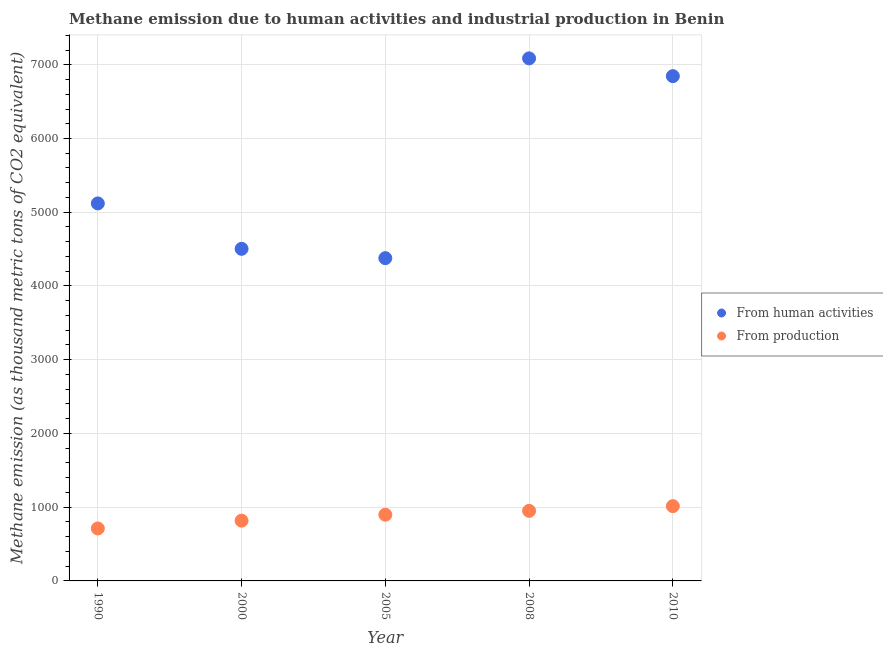How many different coloured dotlines are there?
Your answer should be very brief. 2. What is the amount of emissions from human activities in 1990?
Offer a terse response. 5119.5. Across all years, what is the maximum amount of emissions generated from industries?
Keep it short and to the point. 1014.3. Across all years, what is the minimum amount of emissions generated from industries?
Provide a short and direct response. 711.4. In which year was the amount of emissions from human activities minimum?
Your answer should be compact. 2005. What is the total amount of emissions generated from industries in the graph?
Offer a terse response. 4391.4. What is the difference between the amount of emissions generated from industries in 1990 and that in 2008?
Your answer should be very brief. -239. What is the difference between the amount of emissions from human activities in 1990 and the amount of emissions generated from industries in 2008?
Provide a short and direct response. 4169.1. What is the average amount of emissions from human activities per year?
Give a very brief answer. 5586.56. In the year 1990, what is the difference between the amount of emissions generated from industries and amount of emissions from human activities?
Your answer should be very brief. -4408.1. What is the ratio of the amount of emissions generated from industries in 1990 to that in 2005?
Give a very brief answer. 0.79. Is the amount of emissions from human activities in 2005 less than that in 2008?
Provide a short and direct response. Yes. What is the difference between the highest and the second highest amount of emissions generated from industries?
Offer a terse response. 63.9. What is the difference between the highest and the lowest amount of emissions from human activities?
Offer a very short reply. 2709.3. Is the amount of emissions from human activities strictly greater than the amount of emissions generated from industries over the years?
Ensure brevity in your answer.  Yes. Is the amount of emissions generated from industries strictly less than the amount of emissions from human activities over the years?
Give a very brief answer. Yes. How many dotlines are there?
Provide a short and direct response. 2. How many years are there in the graph?
Offer a very short reply. 5. Does the graph contain grids?
Keep it short and to the point. Yes. What is the title of the graph?
Provide a succinct answer. Methane emission due to human activities and industrial production in Benin. What is the label or title of the Y-axis?
Your response must be concise. Methane emission (as thousand metric tons of CO2 equivalent). What is the Methane emission (as thousand metric tons of CO2 equivalent) in From human activities in 1990?
Your answer should be compact. 5119.5. What is the Methane emission (as thousand metric tons of CO2 equivalent) in From production in 1990?
Provide a short and direct response. 711.4. What is the Methane emission (as thousand metric tons of CO2 equivalent) of From human activities in 2000?
Ensure brevity in your answer.  4503.8. What is the Methane emission (as thousand metric tons of CO2 equivalent) in From production in 2000?
Your answer should be compact. 817.2. What is the Methane emission (as thousand metric tons of CO2 equivalent) of From human activities in 2005?
Offer a very short reply. 4377.3. What is the Methane emission (as thousand metric tons of CO2 equivalent) of From production in 2005?
Your answer should be compact. 898.1. What is the Methane emission (as thousand metric tons of CO2 equivalent) in From human activities in 2008?
Your answer should be very brief. 7086.6. What is the Methane emission (as thousand metric tons of CO2 equivalent) of From production in 2008?
Provide a succinct answer. 950.4. What is the Methane emission (as thousand metric tons of CO2 equivalent) of From human activities in 2010?
Offer a terse response. 6845.6. What is the Methane emission (as thousand metric tons of CO2 equivalent) of From production in 2010?
Your answer should be compact. 1014.3. Across all years, what is the maximum Methane emission (as thousand metric tons of CO2 equivalent) in From human activities?
Offer a terse response. 7086.6. Across all years, what is the maximum Methane emission (as thousand metric tons of CO2 equivalent) in From production?
Make the answer very short. 1014.3. Across all years, what is the minimum Methane emission (as thousand metric tons of CO2 equivalent) of From human activities?
Offer a very short reply. 4377.3. Across all years, what is the minimum Methane emission (as thousand metric tons of CO2 equivalent) in From production?
Provide a short and direct response. 711.4. What is the total Methane emission (as thousand metric tons of CO2 equivalent) in From human activities in the graph?
Ensure brevity in your answer.  2.79e+04. What is the total Methane emission (as thousand metric tons of CO2 equivalent) in From production in the graph?
Keep it short and to the point. 4391.4. What is the difference between the Methane emission (as thousand metric tons of CO2 equivalent) in From human activities in 1990 and that in 2000?
Your answer should be very brief. 615.7. What is the difference between the Methane emission (as thousand metric tons of CO2 equivalent) of From production in 1990 and that in 2000?
Make the answer very short. -105.8. What is the difference between the Methane emission (as thousand metric tons of CO2 equivalent) of From human activities in 1990 and that in 2005?
Offer a very short reply. 742.2. What is the difference between the Methane emission (as thousand metric tons of CO2 equivalent) of From production in 1990 and that in 2005?
Give a very brief answer. -186.7. What is the difference between the Methane emission (as thousand metric tons of CO2 equivalent) in From human activities in 1990 and that in 2008?
Your response must be concise. -1967.1. What is the difference between the Methane emission (as thousand metric tons of CO2 equivalent) of From production in 1990 and that in 2008?
Provide a short and direct response. -239. What is the difference between the Methane emission (as thousand metric tons of CO2 equivalent) of From human activities in 1990 and that in 2010?
Provide a short and direct response. -1726.1. What is the difference between the Methane emission (as thousand metric tons of CO2 equivalent) of From production in 1990 and that in 2010?
Your answer should be very brief. -302.9. What is the difference between the Methane emission (as thousand metric tons of CO2 equivalent) of From human activities in 2000 and that in 2005?
Offer a terse response. 126.5. What is the difference between the Methane emission (as thousand metric tons of CO2 equivalent) in From production in 2000 and that in 2005?
Ensure brevity in your answer.  -80.9. What is the difference between the Methane emission (as thousand metric tons of CO2 equivalent) of From human activities in 2000 and that in 2008?
Make the answer very short. -2582.8. What is the difference between the Methane emission (as thousand metric tons of CO2 equivalent) in From production in 2000 and that in 2008?
Your response must be concise. -133.2. What is the difference between the Methane emission (as thousand metric tons of CO2 equivalent) of From human activities in 2000 and that in 2010?
Make the answer very short. -2341.8. What is the difference between the Methane emission (as thousand metric tons of CO2 equivalent) in From production in 2000 and that in 2010?
Your response must be concise. -197.1. What is the difference between the Methane emission (as thousand metric tons of CO2 equivalent) in From human activities in 2005 and that in 2008?
Your response must be concise. -2709.3. What is the difference between the Methane emission (as thousand metric tons of CO2 equivalent) of From production in 2005 and that in 2008?
Ensure brevity in your answer.  -52.3. What is the difference between the Methane emission (as thousand metric tons of CO2 equivalent) in From human activities in 2005 and that in 2010?
Give a very brief answer. -2468.3. What is the difference between the Methane emission (as thousand metric tons of CO2 equivalent) of From production in 2005 and that in 2010?
Offer a very short reply. -116.2. What is the difference between the Methane emission (as thousand metric tons of CO2 equivalent) of From human activities in 2008 and that in 2010?
Your answer should be very brief. 241. What is the difference between the Methane emission (as thousand metric tons of CO2 equivalent) in From production in 2008 and that in 2010?
Keep it short and to the point. -63.9. What is the difference between the Methane emission (as thousand metric tons of CO2 equivalent) of From human activities in 1990 and the Methane emission (as thousand metric tons of CO2 equivalent) of From production in 2000?
Your answer should be compact. 4302.3. What is the difference between the Methane emission (as thousand metric tons of CO2 equivalent) in From human activities in 1990 and the Methane emission (as thousand metric tons of CO2 equivalent) in From production in 2005?
Make the answer very short. 4221.4. What is the difference between the Methane emission (as thousand metric tons of CO2 equivalent) of From human activities in 1990 and the Methane emission (as thousand metric tons of CO2 equivalent) of From production in 2008?
Ensure brevity in your answer.  4169.1. What is the difference between the Methane emission (as thousand metric tons of CO2 equivalent) in From human activities in 1990 and the Methane emission (as thousand metric tons of CO2 equivalent) in From production in 2010?
Offer a very short reply. 4105.2. What is the difference between the Methane emission (as thousand metric tons of CO2 equivalent) of From human activities in 2000 and the Methane emission (as thousand metric tons of CO2 equivalent) of From production in 2005?
Offer a very short reply. 3605.7. What is the difference between the Methane emission (as thousand metric tons of CO2 equivalent) of From human activities in 2000 and the Methane emission (as thousand metric tons of CO2 equivalent) of From production in 2008?
Ensure brevity in your answer.  3553.4. What is the difference between the Methane emission (as thousand metric tons of CO2 equivalent) of From human activities in 2000 and the Methane emission (as thousand metric tons of CO2 equivalent) of From production in 2010?
Your answer should be very brief. 3489.5. What is the difference between the Methane emission (as thousand metric tons of CO2 equivalent) in From human activities in 2005 and the Methane emission (as thousand metric tons of CO2 equivalent) in From production in 2008?
Offer a terse response. 3426.9. What is the difference between the Methane emission (as thousand metric tons of CO2 equivalent) in From human activities in 2005 and the Methane emission (as thousand metric tons of CO2 equivalent) in From production in 2010?
Make the answer very short. 3363. What is the difference between the Methane emission (as thousand metric tons of CO2 equivalent) in From human activities in 2008 and the Methane emission (as thousand metric tons of CO2 equivalent) in From production in 2010?
Provide a short and direct response. 6072.3. What is the average Methane emission (as thousand metric tons of CO2 equivalent) of From human activities per year?
Make the answer very short. 5586.56. What is the average Methane emission (as thousand metric tons of CO2 equivalent) in From production per year?
Keep it short and to the point. 878.28. In the year 1990, what is the difference between the Methane emission (as thousand metric tons of CO2 equivalent) in From human activities and Methane emission (as thousand metric tons of CO2 equivalent) in From production?
Your answer should be compact. 4408.1. In the year 2000, what is the difference between the Methane emission (as thousand metric tons of CO2 equivalent) of From human activities and Methane emission (as thousand metric tons of CO2 equivalent) of From production?
Provide a succinct answer. 3686.6. In the year 2005, what is the difference between the Methane emission (as thousand metric tons of CO2 equivalent) in From human activities and Methane emission (as thousand metric tons of CO2 equivalent) in From production?
Ensure brevity in your answer.  3479.2. In the year 2008, what is the difference between the Methane emission (as thousand metric tons of CO2 equivalent) of From human activities and Methane emission (as thousand metric tons of CO2 equivalent) of From production?
Keep it short and to the point. 6136.2. In the year 2010, what is the difference between the Methane emission (as thousand metric tons of CO2 equivalent) of From human activities and Methane emission (as thousand metric tons of CO2 equivalent) of From production?
Provide a succinct answer. 5831.3. What is the ratio of the Methane emission (as thousand metric tons of CO2 equivalent) in From human activities in 1990 to that in 2000?
Your answer should be very brief. 1.14. What is the ratio of the Methane emission (as thousand metric tons of CO2 equivalent) in From production in 1990 to that in 2000?
Ensure brevity in your answer.  0.87. What is the ratio of the Methane emission (as thousand metric tons of CO2 equivalent) of From human activities in 1990 to that in 2005?
Your answer should be compact. 1.17. What is the ratio of the Methane emission (as thousand metric tons of CO2 equivalent) in From production in 1990 to that in 2005?
Offer a terse response. 0.79. What is the ratio of the Methane emission (as thousand metric tons of CO2 equivalent) in From human activities in 1990 to that in 2008?
Your answer should be very brief. 0.72. What is the ratio of the Methane emission (as thousand metric tons of CO2 equivalent) of From production in 1990 to that in 2008?
Your answer should be compact. 0.75. What is the ratio of the Methane emission (as thousand metric tons of CO2 equivalent) of From human activities in 1990 to that in 2010?
Provide a short and direct response. 0.75. What is the ratio of the Methane emission (as thousand metric tons of CO2 equivalent) in From production in 1990 to that in 2010?
Make the answer very short. 0.7. What is the ratio of the Methane emission (as thousand metric tons of CO2 equivalent) of From human activities in 2000 to that in 2005?
Your response must be concise. 1.03. What is the ratio of the Methane emission (as thousand metric tons of CO2 equivalent) of From production in 2000 to that in 2005?
Keep it short and to the point. 0.91. What is the ratio of the Methane emission (as thousand metric tons of CO2 equivalent) of From human activities in 2000 to that in 2008?
Your response must be concise. 0.64. What is the ratio of the Methane emission (as thousand metric tons of CO2 equivalent) of From production in 2000 to that in 2008?
Ensure brevity in your answer.  0.86. What is the ratio of the Methane emission (as thousand metric tons of CO2 equivalent) of From human activities in 2000 to that in 2010?
Your response must be concise. 0.66. What is the ratio of the Methane emission (as thousand metric tons of CO2 equivalent) of From production in 2000 to that in 2010?
Offer a terse response. 0.81. What is the ratio of the Methane emission (as thousand metric tons of CO2 equivalent) of From human activities in 2005 to that in 2008?
Ensure brevity in your answer.  0.62. What is the ratio of the Methane emission (as thousand metric tons of CO2 equivalent) in From production in 2005 to that in 2008?
Your response must be concise. 0.94. What is the ratio of the Methane emission (as thousand metric tons of CO2 equivalent) of From human activities in 2005 to that in 2010?
Your answer should be very brief. 0.64. What is the ratio of the Methane emission (as thousand metric tons of CO2 equivalent) in From production in 2005 to that in 2010?
Provide a short and direct response. 0.89. What is the ratio of the Methane emission (as thousand metric tons of CO2 equivalent) of From human activities in 2008 to that in 2010?
Your answer should be compact. 1.04. What is the ratio of the Methane emission (as thousand metric tons of CO2 equivalent) of From production in 2008 to that in 2010?
Provide a succinct answer. 0.94. What is the difference between the highest and the second highest Methane emission (as thousand metric tons of CO2 equivalent) of From human activities?
Provide a succinct answer. 241. What is the difference between the highest and the second highest Methane emission (as thousand metric tons of CO2 equivalent) in From production?
Make the answer very short. 63.9. What is the difference between the highest and the lowest Methane emission (as thousand metric tons of CO2 equivalent) of From human activities?
Your answer should be very brief. 2709.3. What is the difference between the highest and the lowest Methane emission (as thousand metric tons of CO2 equivalent) in From production?
Keep it short and to the point. 302.9. 